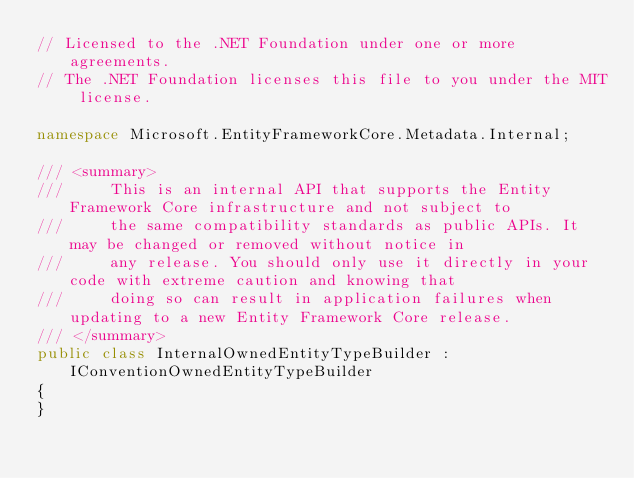Convert code to text. <code><loc_0><loc_0><loc_500><loc_500><_C#_>// Licensed to the .NET Foundation under one or more agreements.
// The .NET Foundation licenses this file to you under the MIT license.

namespace Microsoft.EntityFrameworkCore.Metadata.Internal;

/// <summary>
///     This is an internal API that supports the Entity Framework Core infrastructure and not subject to
///     the same compatibility standards as public APIs. It may be changed or removed without notice in
///     any release. You should only use it directly in your code with extreme caution and knowing that
///     doing so can result in application failures when updating to a new Entity Framework Core release.
/// </summary>
public class InternalOwnedEntityTypeBuilder : IConventionOwnedEntityTypeBuilder
{
}
</code> 